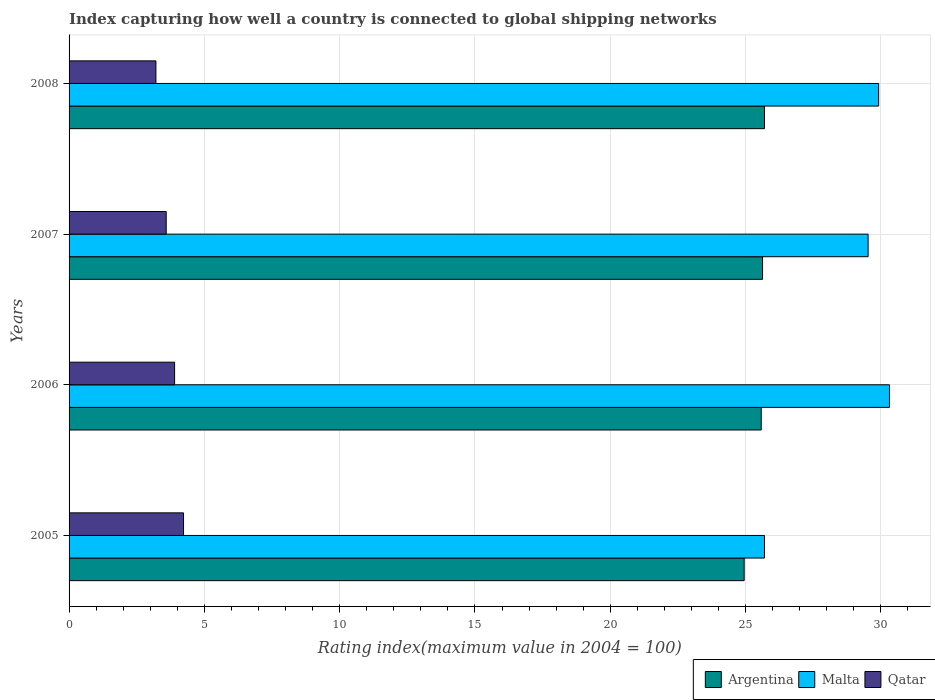How many different coloured bars are there?
Give a very brief answer. 3. Are the number of bars per tick equal to the number of legend labels?
Provide a succinct answer. Yes. Are the number of bars on each tick of the Y-axis equal?
Offer a very short reply. Yes. How many bars are there on the 4th tick from the top?
Make the answer very short. 3. How many bars are there on the 3rd tick from the bottom?
Keep it short and to the point. 3. What is the label of the 4th group of bars from the top?
Your answer should be compact. 2005. What is the rating index in Malta in 2005?
Offer a very short reply. 25.7. Across all years, what is the maximum rating index in Malta?
Your answer should be very brief. 30.32. Across all years, what is the minimum rating index in Argentina?
Your answer should be very brief. 24.95. In which year was the rating index in Malta minimum?
Give a very brief answer. 2005. What is the total rating index in Malta in the graph?
Ensure brevity in your answer.  115.47. What is the difference between the rating index in Argentina in 2005 and that in 2006?
Your answer should be compact. -0.63. What is the difference between the rating index in Argentina in 2005 and the rating index in Qatar in 2008?
Provide a succinct answer. 21.74. What is the average rating index in Malta per year?
Keep it short and to the point. 28.87. In the year 2005, what is the difference between the rating index in Qatar and rating index in Malta?
Offer a terse response. -21.47. What is the ratio of the rating index in Qatar in 2005 to that in 2007?
Provide a succinct answer. 1.18. Is the rating index in Qatar in 2006 less than that in 2008?
Ensure brevity in your answer.  No. What is the difference between the highest and the second highest rating index in Malta?
Offer a terse response. 0.4. What is the difference between the highest and the lowest rating index in Malta?
Your answer should be compact. 4.62. Is the sum of the rating index in Qatar in 2006 and 2007 greater than the maximum rating index in Argentina across all years?
Provide a succinct answer. No. What does the 2nd bar from the top in 2007 represents?
Keep it short and to the point. Malta. What does the 3rd bar from the bottom in 2005 represents?
Keep it short and to the point. Qatar. Are all the bars in the graph horizontal?
Give a very brief answer. Yes. How many years are there in the graph?
Give a very brief answer. 4. What is the difference between two consecutive major ticks on the X-axis?
Your answer should be very brief. 5. Does the graph contain grids?
Provide a succinct answer. Yes. Where does the legend appear in the graph?
Keep it short and to the point. Bottom right. What is the title of the graph?
Your answer should be very brief. Index capturing how well a country is connected to global shipping networks. What is the label or title of the X-axis?
Give a very brief answer. Rating index(maximum value in 2004 = 100). What is the Rating index(maximum value in 2004 = 100) in Argentina in 2005?
Make the answer very short. 24.95. What is the Rating index(maximum value in 2004 = 100) in Malta in 2005?
Your answer should be compact. 25.7. What is the Rating index(maximum value in 2004 = 100) of Qatar in 2005?
Ensure brevity in your answer.  4.23. What is the Rating index(maximum value in 2004 = 100) of Argentina in 2006?
Give a very brief answer. 25.58. What is the Rating index(maximum value in 2004 = 100) of Malta in 2006?
Your answer should be compact. 30.32. What is the Rating index(maximum value in 2004 = 100) in Qatar in 2006?
Ensure brevity in your answer.  3.9. What is the Rating index(maximum value in 2004 = 100) in Argentina in 2007?
Offer a very short reply. 25.63. What is the Rating index(maximum value in 2004 = 100) of Malta in 2007?
Offer a very short reply. 29.53. What is the Rating index(maximum value in 2004 = 100) of Qatar in 2007?
Your answer should be very brief. 3.59. What is the Rating index(maximum value in 2004 = 100) of Argentina in 2008?
Keep it short and to the point. 25.7. What is the Rating index(maximum value in 2004 = 100) of Malta in 2008?
Give a very brief answer. 29.92. What is the Rating index(maximum value in 2004 = 100) of Qatar in 2008?
Your answer should be compact. 3.21. Across all years, what is the maximum Rating index(maximum value in 2004 = 100) in Argentina?
Provide a short and direct response. 25.7. Across all years, what is the maximum Rating index(maximum value in 2004 = 100) in Malta?
Provide a short and direct response. 30.32. Across all years, what is the maximum Rating index(maximum value in 2004 = 100) of Qatar?
Give a very brief answer. 4.23. Across all years, what is the minimum Rating index(maximum value in 2004 = 100) in Argentina?
Keep it short and to the point. 24.95. Across all years, what is the minimum Rating index(maximum value in 2004 = 100) of Malta?
Offer a terse response. 25.7. Across all years, what is the minimum Rating index(maximum value in 2004 = 100) of Qatar?
Ensure brevity in your answer.  3.21. What is the total Rating index(maximum value in 2004 = 100) of Argentina in the graph?
Your response must be concise. 101.86. What is the total Rating index(maximum value in 2004 = 100) of Malta in the graph?
Your answer should be compact. 115.47. What is the total Rating index(maximum value in 2004 = 100) in Qatar in the graph?
Give a very brief answer. 14.93. What is the difference between the Rating index(maximum value in 2004 = 100) in Argentina in 2005 and that in 2006?
Your response must be concise. -0.63. What is the difference between the Rating index(maximum value in 2004 = 100) in Malta in 2005 and that in 2006?
Make the answer very short. -4.62. What is the difference between the Rating index(maximum value in 2004 = 100) of Qatar in 2005 and that in 2006?
Your response must be concise. 0.33. What is the difference between the Rating index(maximum value in 2004 = 100) of Argentina in 2005 and that in 2007?
Make the answer very short. -0.68. What is the difference between the Rating index(maximum value in 2004 = 100) of Malta in 2005 and that in 2007?
Offer a very short reply. -3.83. What is the difference between the Rating index(maximum value in 2004 = 100) of Qatar in 2005 and that in 2007?
Provide a short and direct response. 0.64. What is the difference between the Rating index(maximum value in 2004 = 100) of Argentina in 2005 and that in 2008?
Provide a succinct answer. -0.75. What is the difference between the Rating index(maximum value in 2004 = 100) in Malta in 2005 and that in 2008?
Offer a terse response. -4.22. What is the difference between the Rating index(maximum value in 2004 = 100) of Qatar in 2005 and that in 2008?
Give a very brief answer. 1.02. What is the difference between the Rating index(maximum value in 2004 = 100) of Malta in 2006 and that in 2007?
Provide a short and direct response. 0.79. What is the difference between the Rating index(maximum value in 2004 = 100) in Qatar in 2006 and that in 2007?
Your response must be concise. 0.31. What is the difference between the Rating index(maximum value in 2004 = 100) of Argentina in 2006 and that in 2008?
Your answer should be very brief. -0.12. What is the difference between the Rating index(maximum value in 2004 = 100) in Qatar in 2006 and that in 2008?
Keep it short and to the point. 0.69. What is the difference between the Rating index(maximum value in 2004 = 100) of Argentina in 2007 and that in 2008?
Your answer should be very brief. -0.07. What is the difference between the Rating index(maximum value in 2004 = 100) in Malta in 2007 and that in 2008?
Your answer should be very brief. -0.39. What is the difference between the Rating index(maximum value in 2004 = 100) in Qatar in 2007 and that in 2008?
Ensure brevity in your answer.  0.38. What is the difference between the Rating index(maximum value in 2004 = 100) in Argentina in 2005 and the Rating index(maximum value in 2004 = 100) in Malta in 2006?
Offer a terse response. -5.37. What is the difference between the Rating index(maximum value in 2004 = 100) in Argentina in 2005 and the Rating index(maximum value in 2004 = 100) in Qatar in 2006?
Provide a short and direct response. 21.05. What is the difference between the Rating index(maximum value in 2004 = 100) in Malta in 2005 and the Rating index(maximum value in 2004 = 100) in Qatar in 2006?
Your answer should be compact. 21.8. What is the difference between the Rating index(maximum value in 2004 = 100) in Argentina in 2005 and the Rating index(maximum value in 2004 = 100) in Malta in 2007?
Offer a terse response. -4.58. What is the difference between the Rating index(maximum value in 2004 = 100) in Argentina in 2005 and the Rating index(maximum value in 2004 = 100) in Qatar in 2007?
Provide a succinct answer. 21.36. What is the difference between the Rating index(maximum value in 2004 = 100) in Malta in 2005 and the Rating index(maximum value in 2004 = 100) in Qatar in 2007?
Offer a very short reply. 22.11. What is the difference between the Rating index(maximum value in 2004 = 100) in Argentina in 2005 and the Rating index(maximum value in 2004 = 100) in Malta in 2008?
Offer a very short reply. -4.97. What is the difference between the Rating index(maximum value in 2004 = 100) of Argentina in 2005 and the Rating index(maximum value in 2004 = 100) of Qatar in 2008?
Your answer should be compact. 21.74. What is the difference between the Rating index(maximum value in 2004 = 100) of Malta in 2005 and the Rating index(maximum value in 2004 = 100) of Qatar in 2008?
Offer a terse response. 22.49. What is the difference between the Rating index(maximum value in 2004 = 100) in Argentina in 2006 and the Rating index(maximum value in 2004 = 100) in Malta in 2007?
Ensure brevity in your answer.  -3.95. What is the difference between the Rating index(maximum value in 2004 = 100) in Argentina in 2006 and the Rating index(maximum value in 2004 = 100) in Qatar in 2007?
Offer a terse response. 21.99. What is the difference between the Rating index(maximum value in 2004 = 100) in Malta in 2006 and the Rating index(maximum value in 2004 = 100) in Qatar in 2007?
Your response must be concise. 26.73. What is the difference between the Rating index(maximum value in 2004 = 100) in Argentina in 2006 and the Rating index(maximum value in 2004 = 100) in Malta in 2008?
Provide a succinct answer. -4.34. What is the difference between the Rating index(maximum value in 2004 = 100) of Argentina in 2006 and the Rating index(maximum value in 2004 = 100) of Qatar in 2008?
Your answer should be compact. 22.37. What is the difference between the Rating index(maximum value in 2004 = 100) of Malta in 2006 and the Rating index(maximum value in 2004 = 100) of Qatar in 2008?
Provide a succinct answer. 27.11. What is the difference between the Rating index(maximum value in 2004 = 100) in Argentina in 2007 and the Rating index(maximum value in 2004 = 100) in Malta in 2008?
Your answer should be very brief. -4.29. What is the difference between the Rating index(maximum value in 2004 = 100) of Argentina in 2007 and the Rating index(maximum value in 2004 = 100) of Qatar in 2008?
Your answer should be compact. 22.42. What is the difference between the Rating index(maximum value in 2004 = 100) of Malta in 2007 and the Rating index(maximum value in 2004 = 100) of Qatar in 2008?
Keep it short and to the point. 26.32. What is the average Rating index(maximum value in 2004 = 100) of Argentina per year?
Make the answer very short. 25.46. What is the average Rating index(maximum value in 2004 = 100) of Malta per year?
Ensure brevity in your answer.  28.87. What is the average Rating index(maximum value in 2004 = 100) in Qatar per year?
Offer a very short reply. 3.73. In the year 2005, what is the difference between the Rating index(maximum value in 2004 = 100) in Argentina and Rating index(maximum value in 2004 = 100) in Malta?
Make the answer very short. -0.75. In the year 2005, what is the difference between the Rating index(maximum value in 2004 = 100) in Argentina and Rating index(maximum value in 2004 = 100) in Qatar?
Give a very brief answer. 20.72. In the year 2005, what is the difference between the Rating index(maximum value in 2004 = 100) in Malta and Rating index(maximum value in 2004 = 100) in Qatar?
Offer a very short reply. 21.47. In the year 2006, what is the difference between the Rating index(maximum value in 2004 = 100) of Argentina and Rating index(maximum value in 2004 = 100) of Malta?
Make the answer very short. -4.74. In the year 2006, what is the difference between the Rating index(maximum value in 2004 = 100) of Argentina and Rating index(maximum value in 2004 = 100) of Qatar?
Ensure brevity in your answer.  21.68. In the year 2006, what is the difference between the Rating index(maximum value in 2004 = 100) of Malta and Rating index(maximum value in 2004 = 100) of Qatar?
Offer a very short reply. 26.42. In the year 2007, what is the difference between the Rating index(maximum value in 2004 = 100) in Argentina and Rating index(maximum value in 2004 = 100) in Qatar?
Keep it short and to the point. 22.04. In the year 2007, what is the difference between the Rating index(maximum value in 2004 = 100) of Malta and Rating index(maximum value in 2004 = 100) of Qatar?
Offer a very short reply. 25.94. In the year 2008, what is the difference between the Rating index(maximum value in 2004 = 100) in Argentina and Rating index(maximum value in 2004 = 100) in Malta?
Give a very brief answer. -4.22. In the year 2008, what is the difference between the Rating index(maximum value in 2004 = 100) in Argentina and Rating index(maximum value in 2004 = 100) in Qatar?
Give a very brief answer. 22.49. In the year 2008, what is the difference between the Rating index(maximum value in 2004 = 100) in Malta and Rating index(maximum value in 2004 = 100) in Qatar?
Your answer should be compact. 26.71. What is the ratio of the Rating index(maximum value in 2004 = 100) in Argentina in 2005 to that in 2006?
Provide a succinct answer. 0.98. What is the ratio of the Rating index(maximum value in 2004 = 100) in Malta in 2005 to that in 2006?
Offer a very short reply. 0.85. What is the ratio of the Rating index(maximum value in 2004 = 100) of Qatar in 2005 to that in 2006?
Keep it short and to the point. 1.08. What is the ratio of the Rating index(maximum value in 2004 = 100) of Argentina in 2005 to that in 2007?
Make the answer very short. 0.97. What is the ratio of the Rating index(maximum value in 2004 = 100) of Malta in 2005 to that in 2007?
Your response must be concise. 0.87. What is the ratio of the Rating index(maximum value in 2004 = 100) of Qatar in 2005 to that in 2007?
Your response must be concise. 1.18. What is the ratio of the Rating index(maximum value in 2004 = 100) of Argentina in 2005 to that in 2008?
Provide a succinct answer. 0.97. What is the ratio of the Rating index(maximum value in 2004 = 100) of Malta in 2005 to that in 2008?
Ensure brevity in your answer.  0.86. What is the ratio of the Rating index(maximum value in 2004 = 100) of Qatar in 2005 to that in 2008?
Make the answer very short. 1.32. What is the ratio of the Rating index(maximum value in 2004 = 100) in Argentina in 2006 to that in 2007?
Your answer should be compact. 1. What is the ratio of the Rating index(maximum value in 2004 = 100) in Malta in 2006 to that in 2007?
Keep it short and to the point. 1.03. What is the ratio of the Rating index(maximum value in 2004 = 100) in Qatar in 2006 to that in 2007?
Make the answer very short. 1.09. What is the ratio of the Rating index(maximum value in 2004 = 100) of Argentina in 2006 to that in 2008?
Keep it short and to the point. 1. What is the ratio of the Rating index(maximum value in 2004 = 100) in Malta in 2006 to that in 2008?
Keep it short and to the point. 1.01. What is the ratio of the Rating index(maximum value in 2004 = 100) in Qatar in 2006 to that in 2008?
Your answer should be very brief. 1.22. What is the ratio of the Rating index(maximum value in 2004 = 100) in Argentina in 2007 to that in 2008?
Make the answer very short. 1. What is the ratio of the Rating index(maximum value in 2004 = 100) of Malta in 2007 to that in 2008?
Keep it short and to the point. 0.99. What is the ratio of the Rating index(maximum value in 2004 = 100) in Qatar in 2007 to that in 2008?
Your response must be concise. 1.12. What is the difference between the highest and the second highest Rating index(maximum value in 2004 = 100) in Argentina?
Keep it short and to the point. 0.07. What is the difference between the highest and the second highest Rating index(maximum value in 2004 = 100) of Qatar?
Give a very brief answer. 0.33. What is the difference between the highest and the lowest Rating index(maximum value in 2004 = 100) of Malta?
Provide a short and direct response. 4.62. What is the difference between the highest and the lowest Rating index(maximum value in 2004 = 100) of Qatar?
Your answer should be compact. 1.02. 